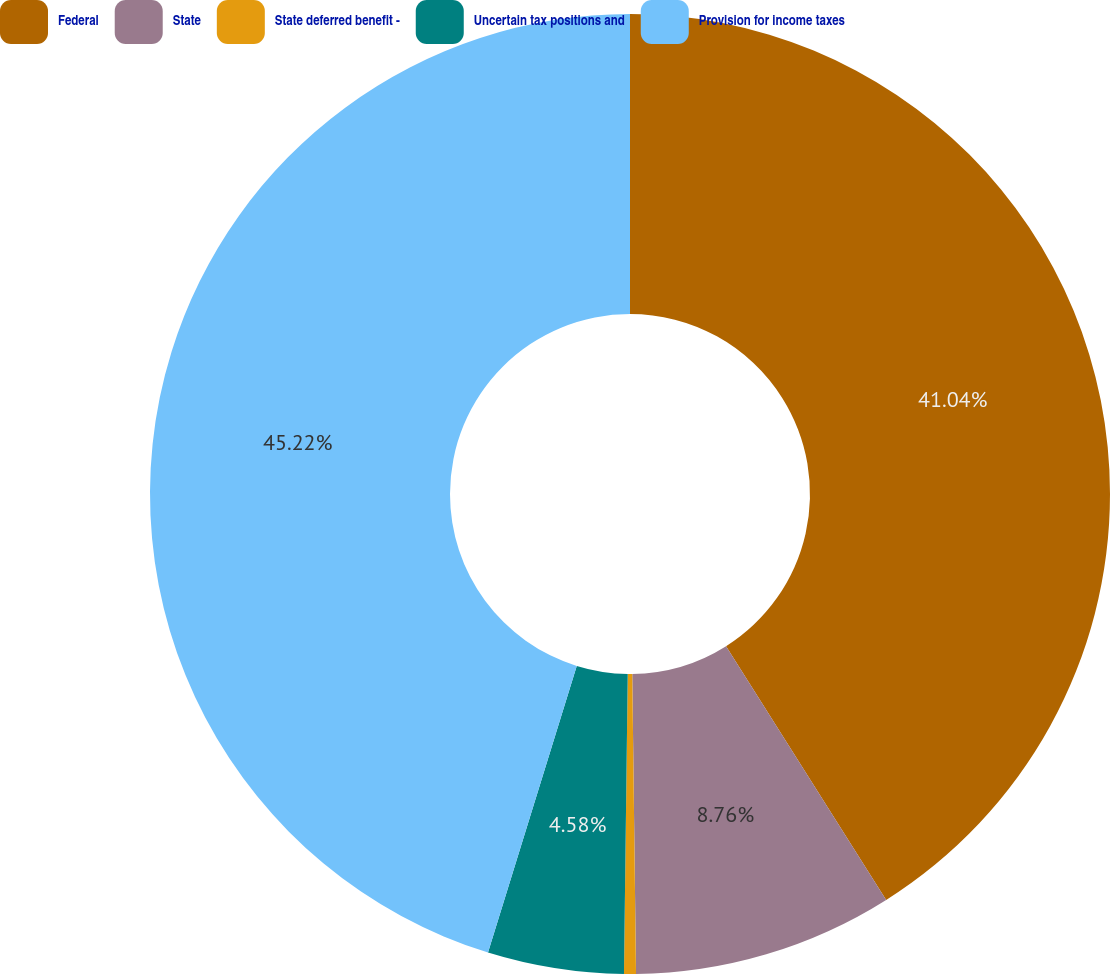Convert chart. <chart><loc_0><loc_0><loc_500><loc_500><pie_chart><fcel>Federal<fcel>State<fcel>State deferred benefit -<fcel>Uncertain tax positions and<fcel>Provision for income taxes<nl><fcel>41.04%<fcel>8.76%<fcel>0.4%<fcel>4.58%<fcel>45.22%<nl></chart> 